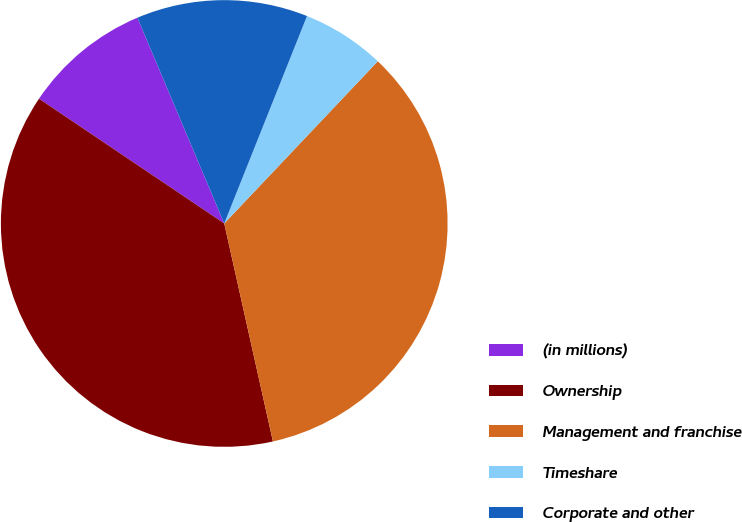<chart> <loc_0><loc_0><loc_500><loc_500><pie_chart><fcel>(in millions)<fcel>Ownership<fcel>Management and franchise<fcel>Timeshare<fcel>Corporate and other<nl><fcel>9.21%<fcel>37.93%<fcel>34.44%<fcel>6.02%<fcel>12.4%<nl></chart> 